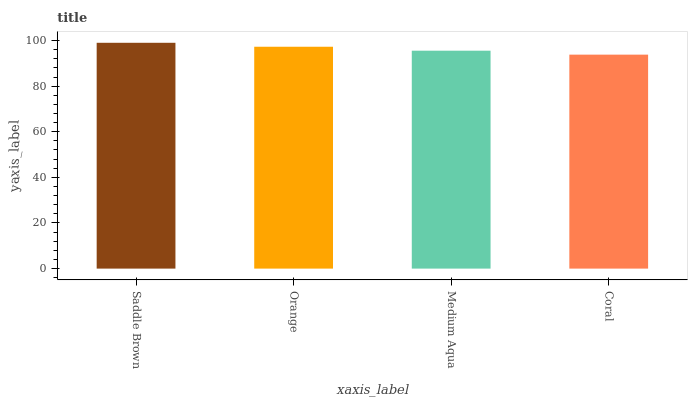Is Coral the minimum?
Answer yes or no. Yes. Is Saddle Brown the maximum?
Answer yes or no. Yes. Is Orange the minimum?
Answer yes or no. No. Is Orange the maximum?
Answer yes or no. No. Is Saddle Brown greater than Orange?
Answer yes or no. Yes. Is Orange less than Saddle Brown?
Answer yes or no. Yes. Is Orange greater than Saddle Brown?
Answer yes or no. No. Is Saddle Brown less than Orange?
Answer yes or no. No. Is Orange the high median?
Answer yes or no. Yes. Is Medium Aqua the low median?
Answer yes or no. Yes. Is Coral the high median?
Answer yes or no. No. Is Orange the low median?
Answer yes or no. No. 